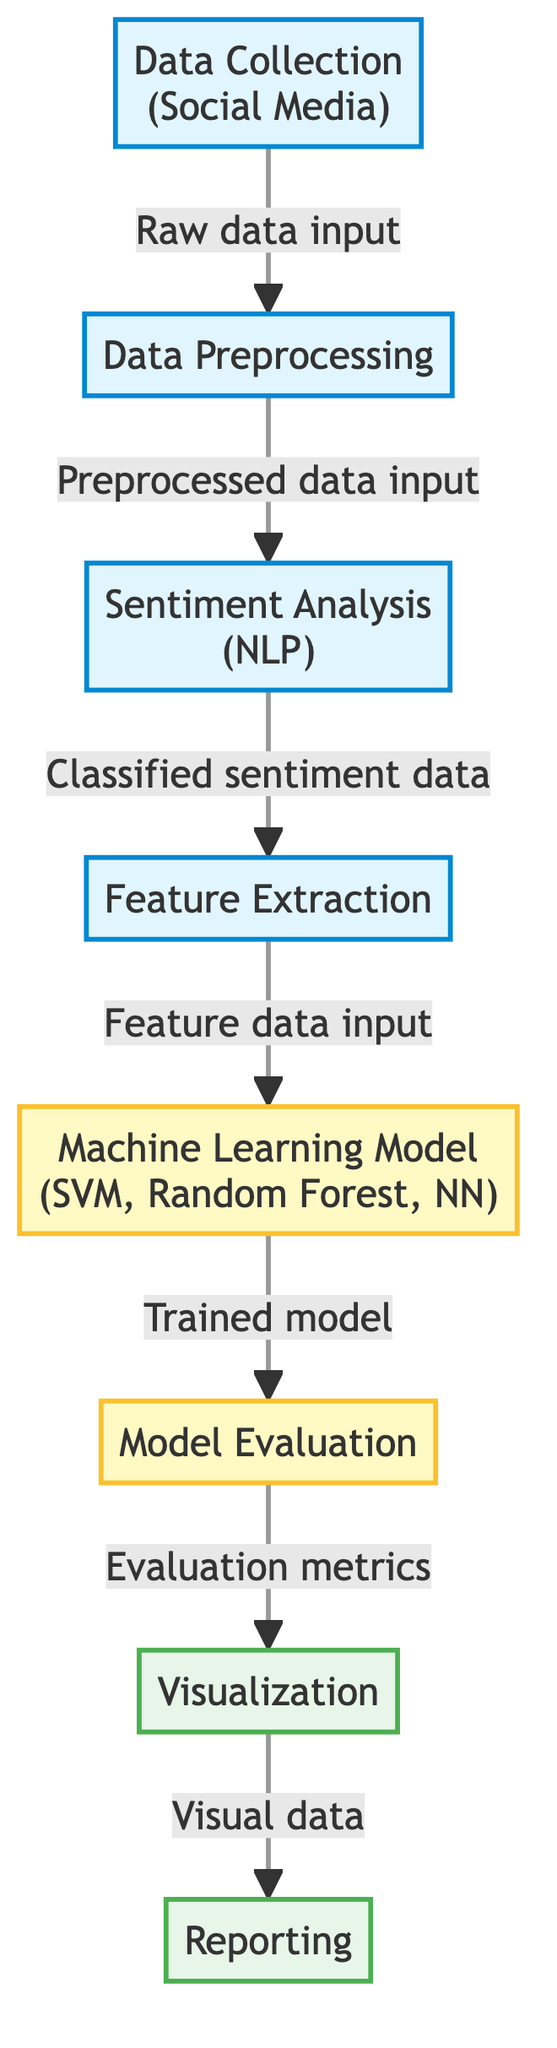What is the first step in the diagram? The first node in the diagram is labeled "Data Collection (Social Media)," which indicates that the initial step involves gathering data from social media platforms.
Answer: Data Collection (Social Media) How many processes are shown in the diagram? The diagram consists of six processes, each represented by a distinct node that outlines specific stages in the machine learning pipeline.
Answer: 6 What type of analysis is performed after data preprocessing? The node following "Data Preprocessing" is "Sentiment Analysis (NLP)," which clarifies that sentiment analysis, using natural language processing techniques, is undertaken next.
Answer: Sentiment Analysis (NLP) Which machine learning models are mentioned in the diagram? The relevant node lists three different models: “SVM,” “Random Forest,” and “NN,” indicating the variety of machine learning techniques that can be applied in this analysis.
Answer: SVM, Random Forest, NN What is the output of the model evaluation step? The node labeled "Model Evaluation" points to "Evaluation metrics," which signifies that the output of this step consists of various metrics used to assess the model's performance.
Answer: Evaluation metrics In which step does feature extraction occur? Feature extraction takes place after sentiment analysis and precedes the machine learning model training, as shown in the flow of steps within the diagram.
Answer: After Sentiment Analysis What is the final output of the diagram? The last node in the flow is labeled "Reporting," which indicates that the ultimate output of this process involves generating reports of the analyzed data for stakeholders or fans.
Answer: Reporting Which node follows feature extraction? The node that directly follows "Feature Extraction" is "Machine Learning Model (SVM, Random Forest, NN)," indicating the sequence proceeds to model training based on the extracted features.
Answer: Machine Learning Model (SVM, Random Forest, NN) What role does visualization play in the process? After the model evaluation step, the process leads to "Visualization," emphasizing that this part involves displaying the results visually for easier interpretation and analysis.
Answer: Visualization 